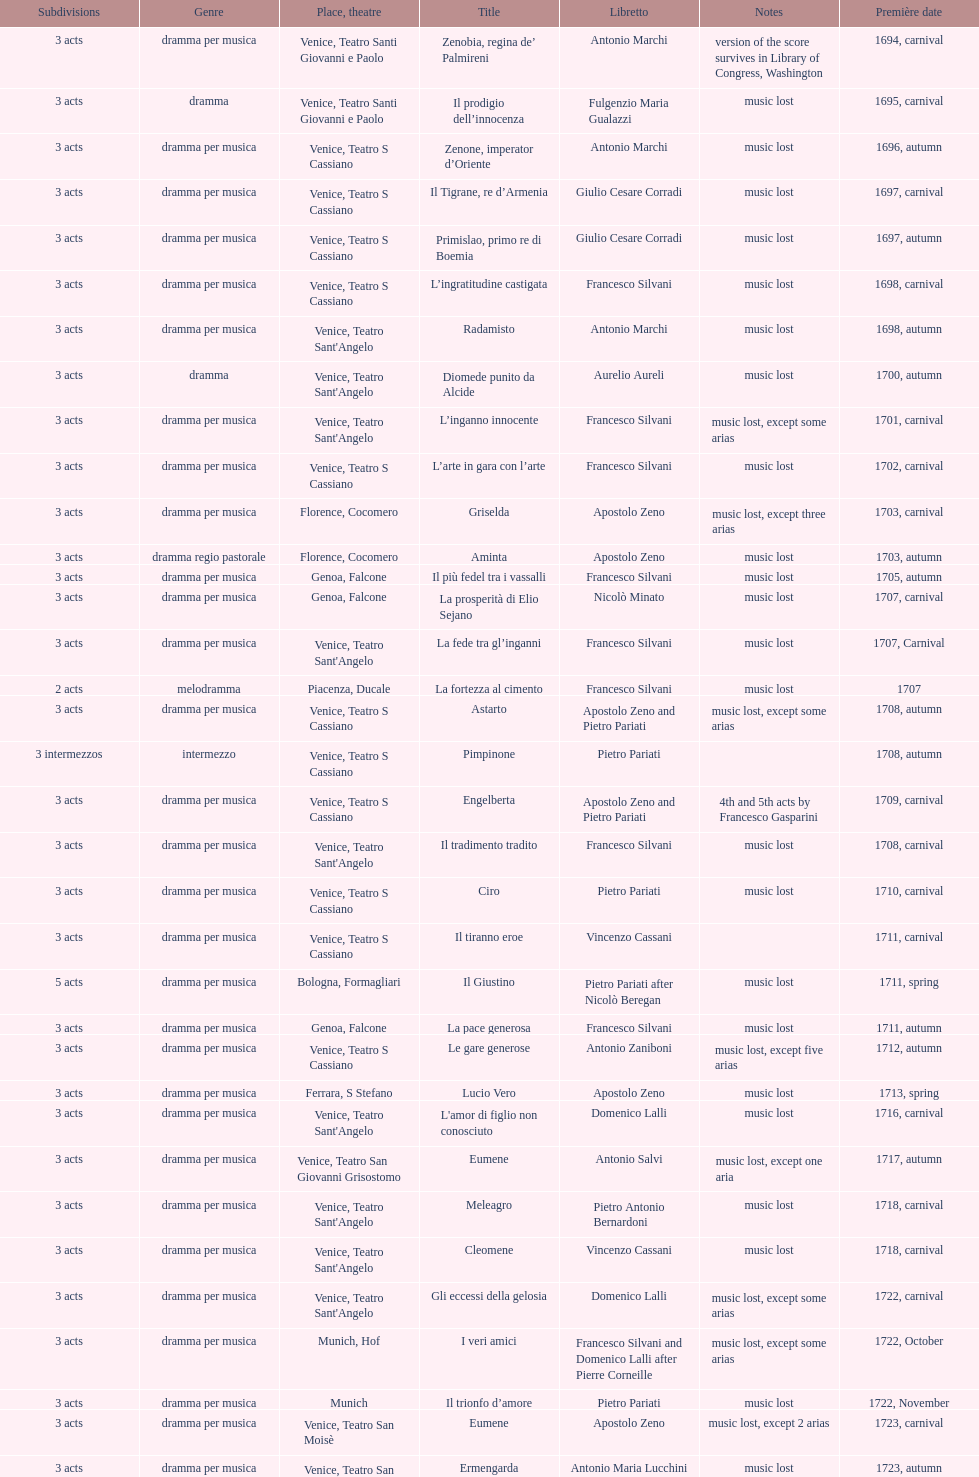Which opera has at least 5 acts? Il Giustino. 